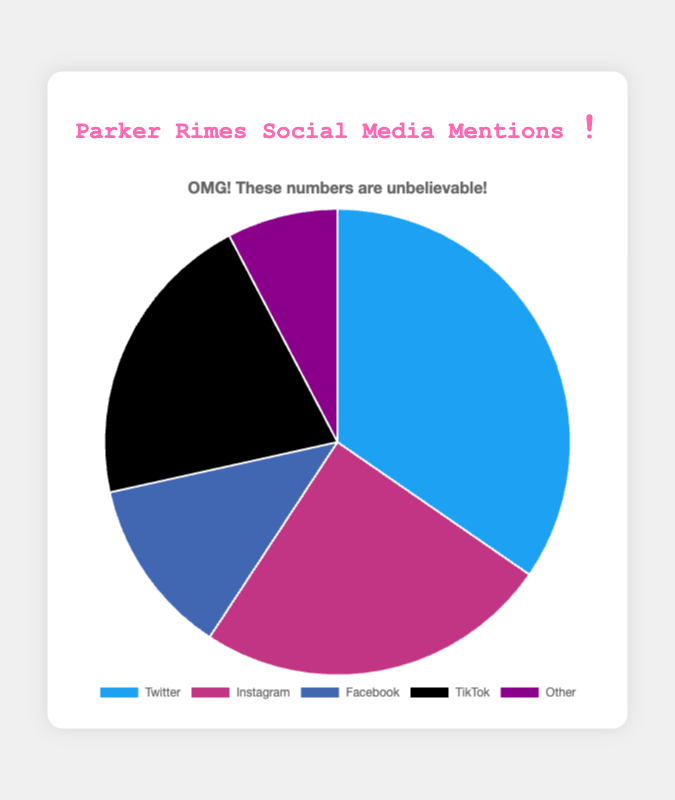Which platform has the highest number of mentions? The platform with the largest section in the pie chart represents the highest number of mentions. Here, it is Twitter with 4500 mentions.
Answer: Twitter Which platform has the lowest number of mentions? The smallest section in the pie chart represents the platform with the fewest mentions. "Other" has the smallest slice with 1000 mentions.
Answer: Other What is the combined number of mentions on Instagram and TikTok? Add the mentions from Instagram and TikTok: 3200 (Instagram) + 2700 (TikTok) = 5900 mentions.
Answer: 5900 How many more mentions does Facebook have compared to "Other"? Subtract the mentions of "Other" from Facebook: 1600 (Facebook) - 1000 (Other) = 600 mentions more.
Answer: 600 Which platform has more mentions, Instagram or TikTok? Compare the mentions between Instagram (3200) and TikTok (2700). Instagram has more mentions.
Answer: Instagram What is the total number of mentions across all platforms? Sum the mentions: 4500 (Twitter) + 3200 (Instagram) + 1600 (Facebook) + 2700 (TikTok) + 1000 (Other) = 13000 mentions.
Answer: 13000 What percentage of total mentions does Twitter have? (Twitter mentions / Total mentions) * 100 = (4500 / 13000) * 100 ≈ 34.62%
Answer: 34.62% Which two platforms combined have the fewest mentions? Add the mentions for each pair and find the minimum. "Facebook + Other" is 1600 + 1000 = 2600 mentions, which is the smallest sum.
Answer: Facebook and Other By how many mentions does Twitter surpass TikTok and "Other" combined? First, sum TikTok and "Other": 2700 (TikTok) + 1000 (Other) = 3700. Then subtract this sum from Twitter: 4500 (Twitter) - 3700 = 800 mentions more.
Answer: 800 What is the average number of mentions across all platforms? Total mentions / Number of platforms = 13000 / 5 = 2600 mentions per platform.
Answer: 2600 